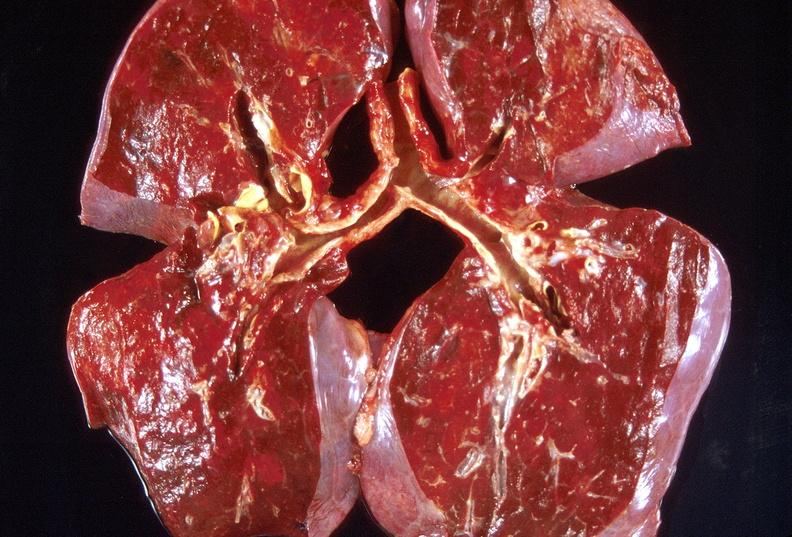what does this image show?
Answer the question using a single word or phrase. Lung 